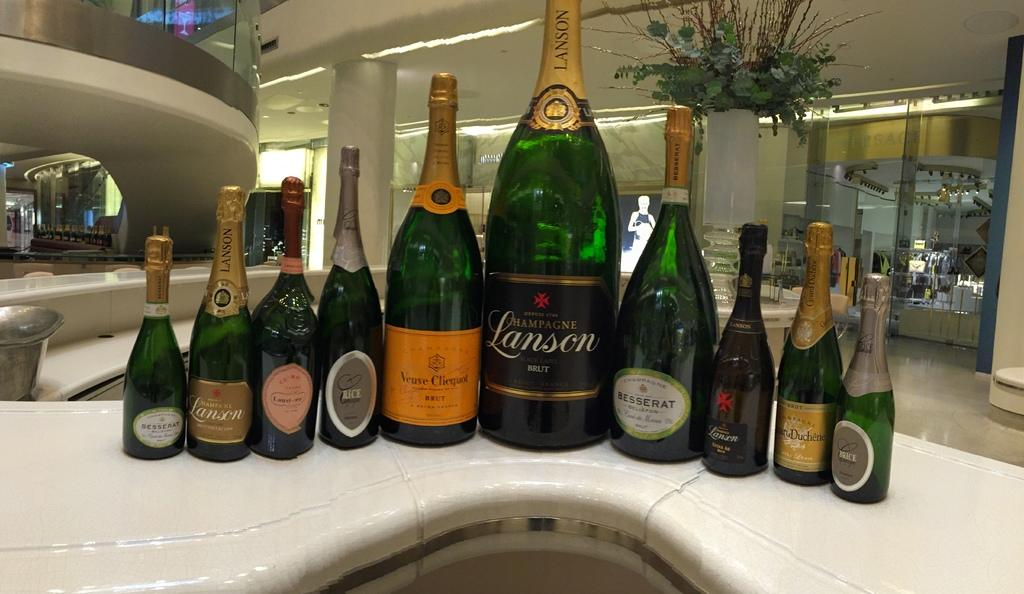<image>
Share a concise interpretation of the image provided. A large bottle of Champagne Lanson is surrounded by smaller bottles. 